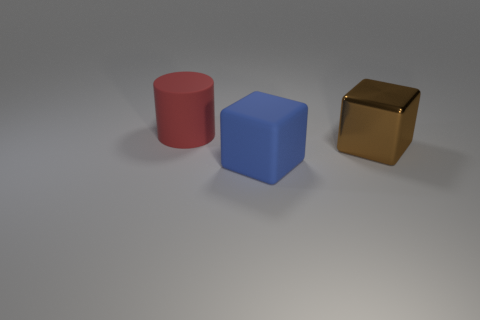Is there any other thing that has the same material as the brown block?
Your answer should be very brief. No. Is there any other thing that is the same shape as the blue matte object?
Offer a terse response. Yes. How many things are either large things behind the blue object or blue matte blocks?
Your response must be concise. 3. Is the brown object the same shape as the big blue thing?
Your answer should be compact. Yes. The big matte cube has what color?
Give a very brief answer. Blue. What number of small things are blue rubber things or blocks?
Your response must be concise. 0. Do the matte thing that is right of the large red matte cylinder and the matte thing behind the large metallic thing have the same size?
Your response must be concise. Yes. There is a brown metallic object that is the same shape as the blue thing; what size is it?
Give a very brief answer. Large. Are there more brown things that are behind the large red thing than metal cubes right of the brown shiny object?
Offer a very short reply. No. The big thing that is to the right of the large red matte cylinder and behind the blue matte block is made of what material?
Offer a terse response. Metal. 